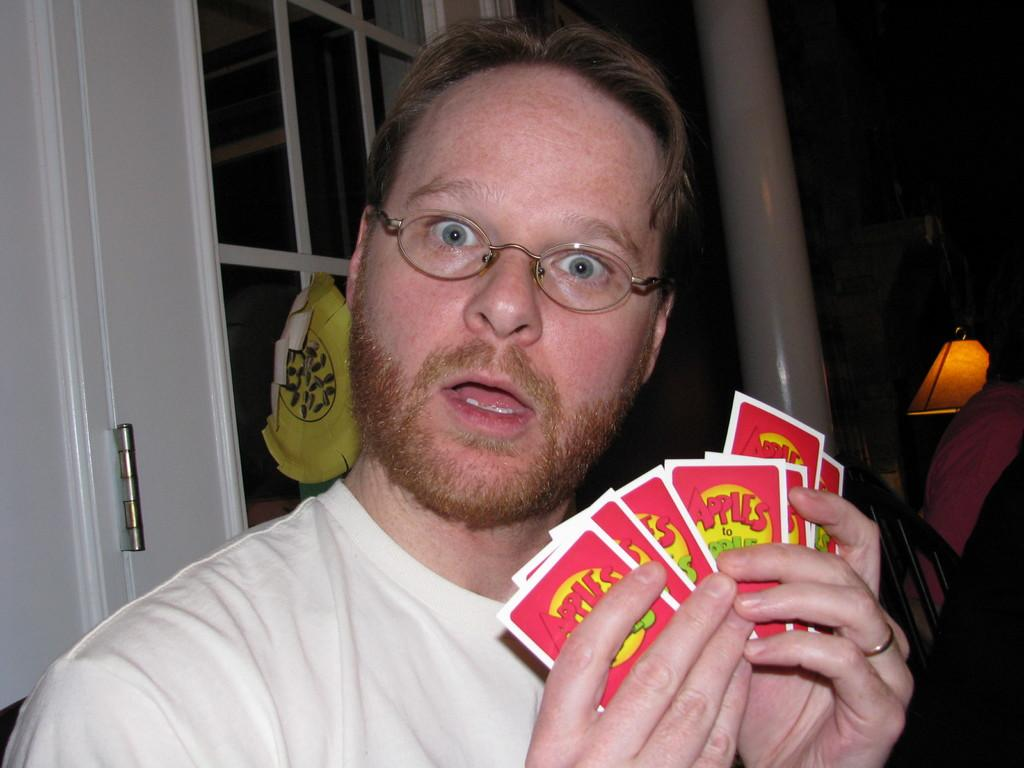What is the man in the image doing? The man is standing in the image and holding some cards. What can be seen in the background of the image? There is a window and a lamp in the background of the image. What type of sofa is visible in the image? There is no sofa present in the image. How does the acoustics of the room affect the sound of the cards being shuffled? The image does not provide any information about the acoustics of the room, so it cannot be determined how they might affect the sound of the cards being shuffled. 